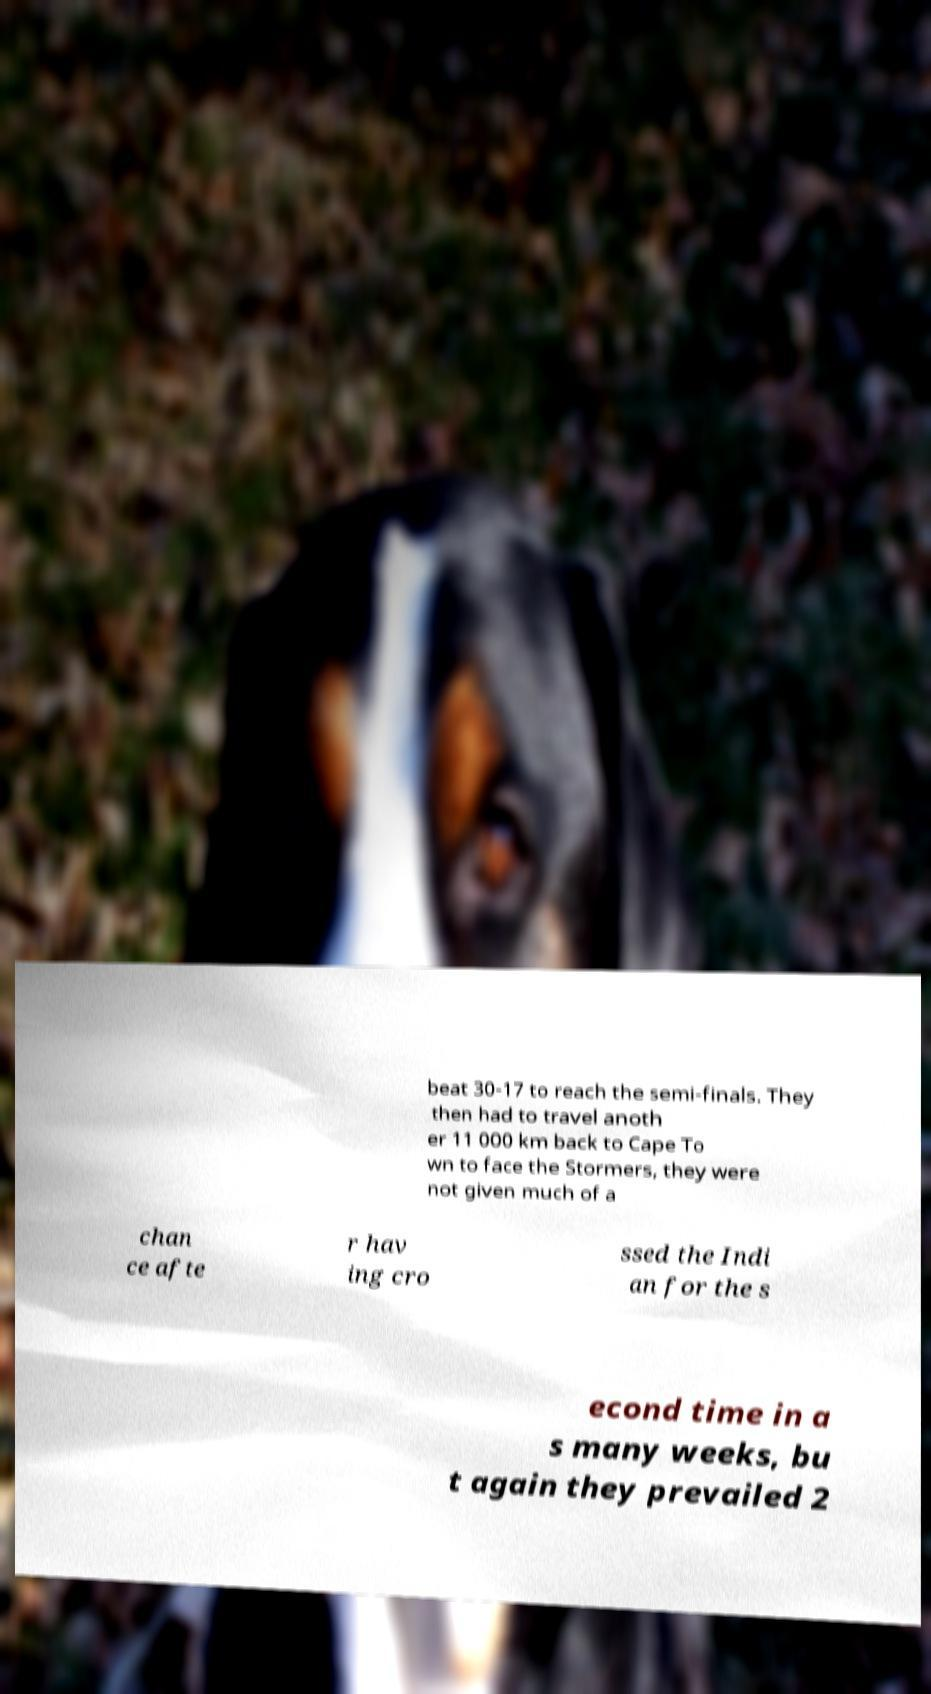Can you read and provide the text displayed in the image?This photo seems to have some interesting text. Can you extract and type it out for me? beat 30-17 to reach the semi-finals. They then had to travel anoth er 11 000 km back to Cape To wn to face the Stormers, they were not given much of a chan ce afte r hav ing cro ssed the Indi an for the s econd time in a s many weeks, bu t again they prevailed 2 